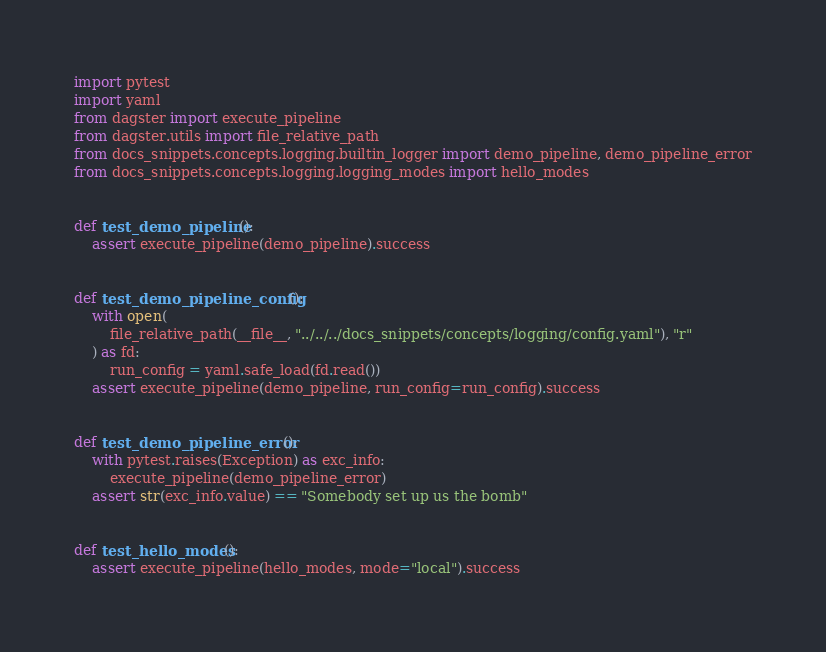<code> <loc_0><loc_0><loc_500><loc_500><_Python_>import pytest
import yaml
from dagster import execute_pipeline
from dagster.utils import file_relative_path
from docs_snippets.concepts.logging.builtin_logger import demo_pipeline, demo_pipeline_error
from docs_snippets.concepts.logging.logging_modes import hello_modes


def test_demo_pipeline():
    assert execute_pipeline(demo_pipeline).success


def test_demo_pipeline_config():
    with open(
        file_relative_path(__file__, "../../../docs_snippets/concepts/logging/config.yaml"), "r"
    ) as fd:
        run_config = yaml.safe_load(fd.read())
    assert execute_pipeline(demo_pipeline, run_config=run_config).success


def test_demo_pipeline_error():
    with pytest.raises(Exception) as exc_info:
        execute_pipeline(demo_pipeline_error)
    assert str(exc_info.value) == "Somebody set up us the bomb"


def test_hello_modes():
    assert execute_pipeline(hello_modes, mode="local").success
</code> 